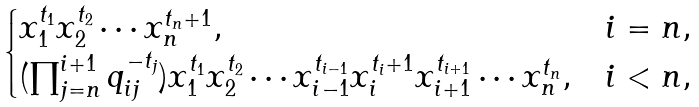Convert formula to latex. <formula><loc_0><loc_0><loc_500><loc_500>\begin{cases} x _ { 1 } ^ { t _ { 1 } } x _ { 2 } ^ { t _ { 2 } } \cdots x _ { n } ^ { t _ { n } + 1 } , & i = n , \\ ( \prod _ { j = n } ^ { i + 1 } q _ { i j } ^ { - t _ { j } } ) x _ { 1 } ^ { t _ { 1 } } x _ { 2 } ^ { t _ { 2 } } \cdots x _ { i - 1 } ^ { t _ { i - 1 } } x _ { i } ^ { t _ { i } + 1 } x _ { i + 1 } ^ { t _ { i + 1 } } \cdots x _ { n } ^ { t _ { n } } , & i < n , \end{cases}</formula> 